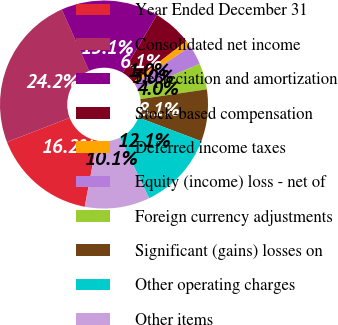Convert chart to OTSL. <chart><loc_0><loc_0><loc_500><loc_500><pie_chart><fcel>Year Ended December 31<fcel>Consolidated net income<fcel>Depreciation and amortization<fcel>Stock-based compensation<fcel>Deferred income taxes<fcel>Equity (income) loss - net of<fcel>Foreign currency adjustments<fcel>Significant (gains) losses on<fcel>Other operating charges<fcel>Other items<nl><fcel>16.16%<fcel>24.23%<fcel>15.15%<fcel>6.06%<fcel>1.02%<fcel>3.04%<fcel>4.05%<fcel>8.08%<fcel>12.12%<fcel>10.1%<nl></chart> 